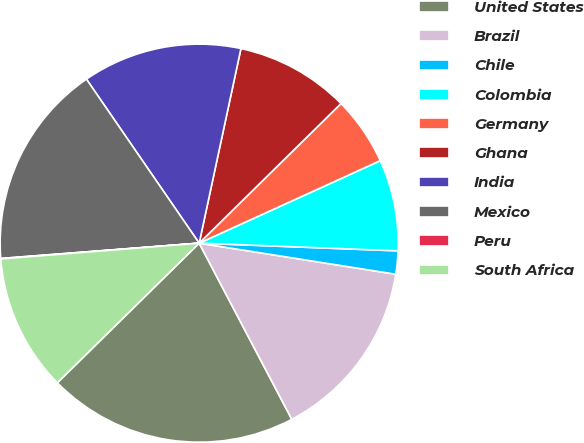Convert chart to OTSL. <chart><loc_0><loc_0><loc_500><loc_500><pie_chart><fcel>United States<fcel>Brazil<fcel>Chile<fcel>Colombia<fcel>Germany<fcel>Ghana<fcel>India<fcel>Mexico<fcel>Peru<fcel>South Africa<nl><fcel>20.33%<fcel>14.8%<fcel>1.88%<fcel>7.42%<fcel>5.57%<fcel>9.26%<fcel>12.95%<fcel>16.64%<fcel>0.04%<fcel>11.11%<nl></chart> 